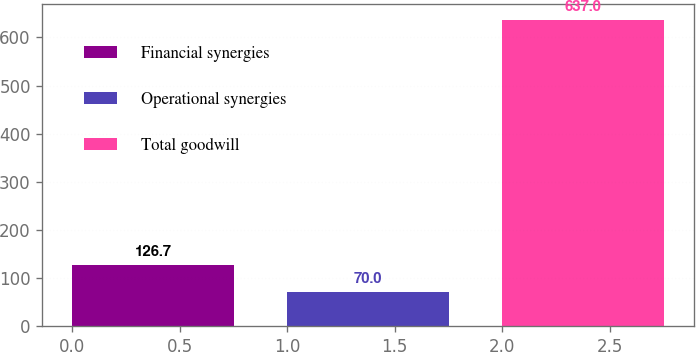Convert chart. <chart><loc_0><loc_0><loc_500><loc_500><bar_chart><fcel>Financial synergies<fcel>Operational synergies<fcel>Total goodwill<nl><fcel>126.7<fcel>70<fcel>637<nl></chart> 